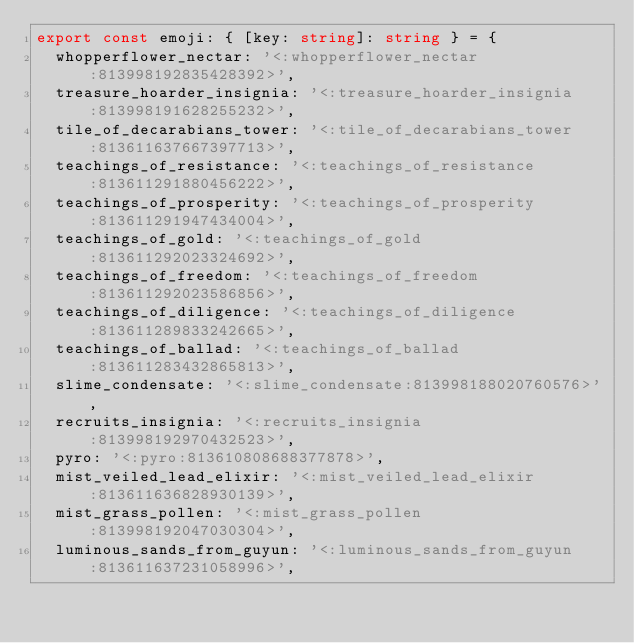<code> <loc_0><loc_0><loc_500><loc_500><_TypeScript_>export const emoji: { [key: string]: string } = {
  whopperflower_nectar: '<:whopperflower_nectar:813998192835428392>',
  treasure_hoarder_insignia: '<:treasure_hoarder_insignia:813998191628255232>',
  tile_of_decarabians_tower: '<:tile_of_decarabians_tower:813611637667397713>',
  teachings_of_resistance: '<:teachings_of_resistance:813611291880456222>',
  teachings_of_prosperity: '<:teachings_of_prosperity:813611291947434004>',
  teachings_of_gold: '<:teachings_of_gold:813611292023324692>',
  teachings_of_freedom: '<:teachings_of_freedom:813611292023586856>',
  teachings_of_diligence: '<:teachings_of_diligence:813611289833242665>',
  teachings_of_ballad: '<:teachings_of_ballad:813611283432865813>',
  slime_condensate: '<:slime_condensate:813998188020760576>',
  recruits_insignia: '<:recruits_insignia:813998192970432523>',
  pyro: '<:pyro:813610808688377878>',
  mist_veiled_lead_elixir: '<:mist_veiled_lead_elixir:813611636828930139>',
  mist_grass_pollen: '<:mist_grass_pollen:813998192047030304>',
  luminous_sands_from_guyun: '<:luminous_sands_from_guyun:813611637231058996>',</code> 